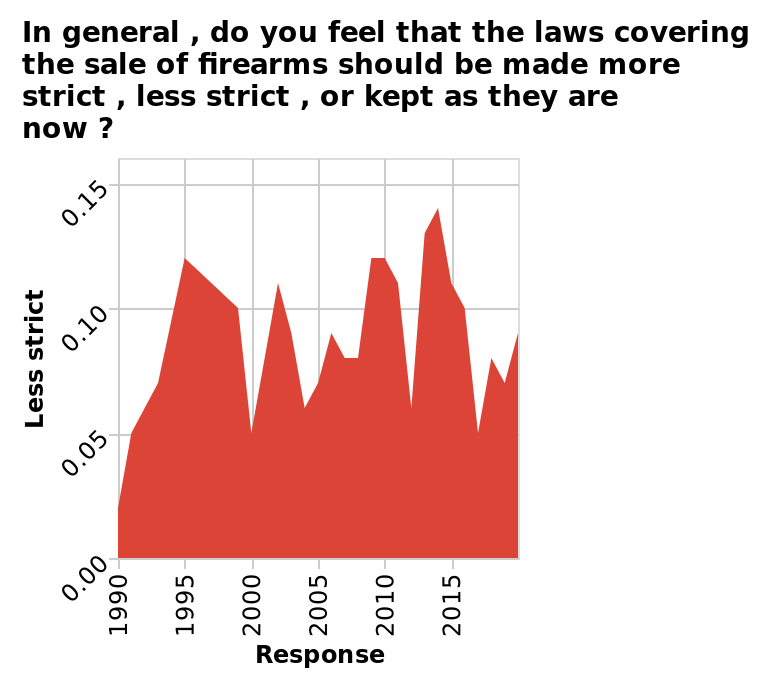<image>
Is there a pattern or trend in the fluctuations of responses over the years? While fluctuations in responses can vary depending on the specific issue and context, it is possible to observe patterns or trends over time. These patterns may be influenced by cultural shifts, generational differences, or changes in public discourse. Can you explain why there is often a drop in responses to people wanting less strict laws? The drop in responses to people wanting less strict laws could be attributed to various factors such as shifting social norms, significant events that highlight the importance of strict laws, or changes in political landscapes. 